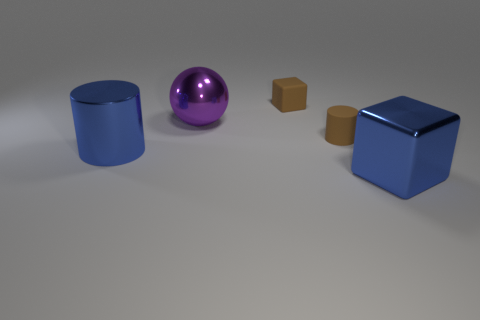Add 3 blue things. How many objects exist? 8 Subtract all blocks. How many objects are left? 3 Add 5 large things. How many large things exist? 8 Subtract 0 gray cubes. How many objects are left? 5 Subtract all small purple metal balls. Subtract all small matte cylinders. How many objects are left? 4 Add 4 blue objects. How many blue objects are left? 6 